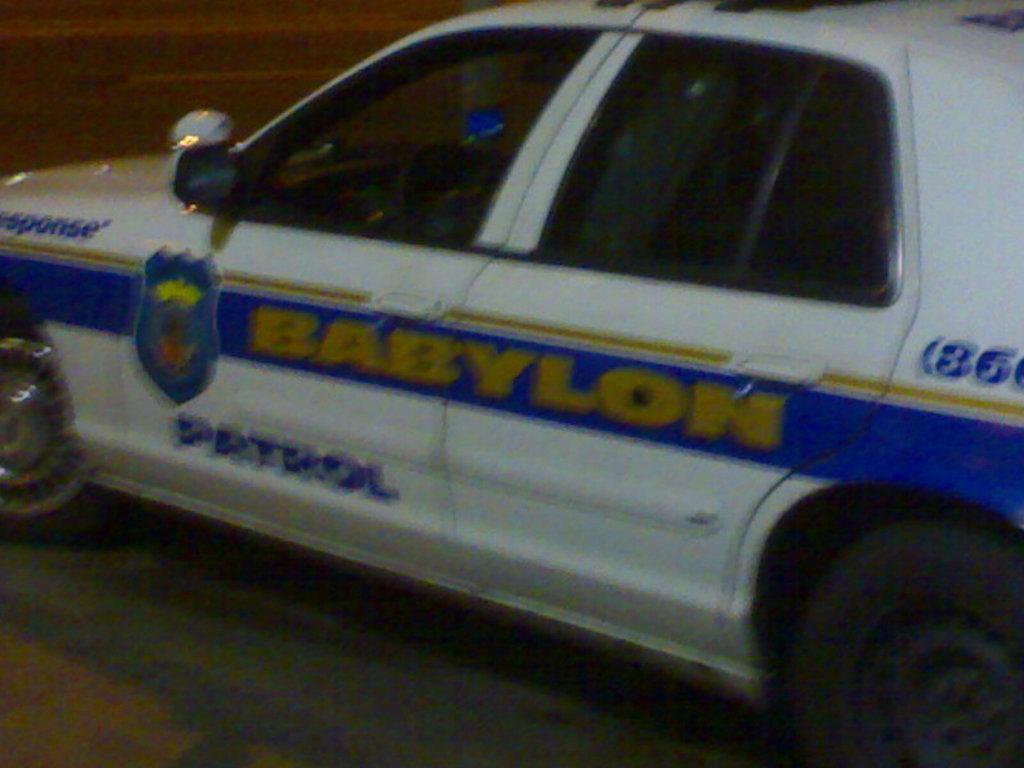What is the main subject of the image? The main subject of the image is a vehicle. What is the vehicle doing in the image? The vehicle is moving on the road. What type of cracker is being used as a spot to punish the vehicle in the image? There is no cracker or punishment present in the image; it simply shows a vehicle moving on the road. 